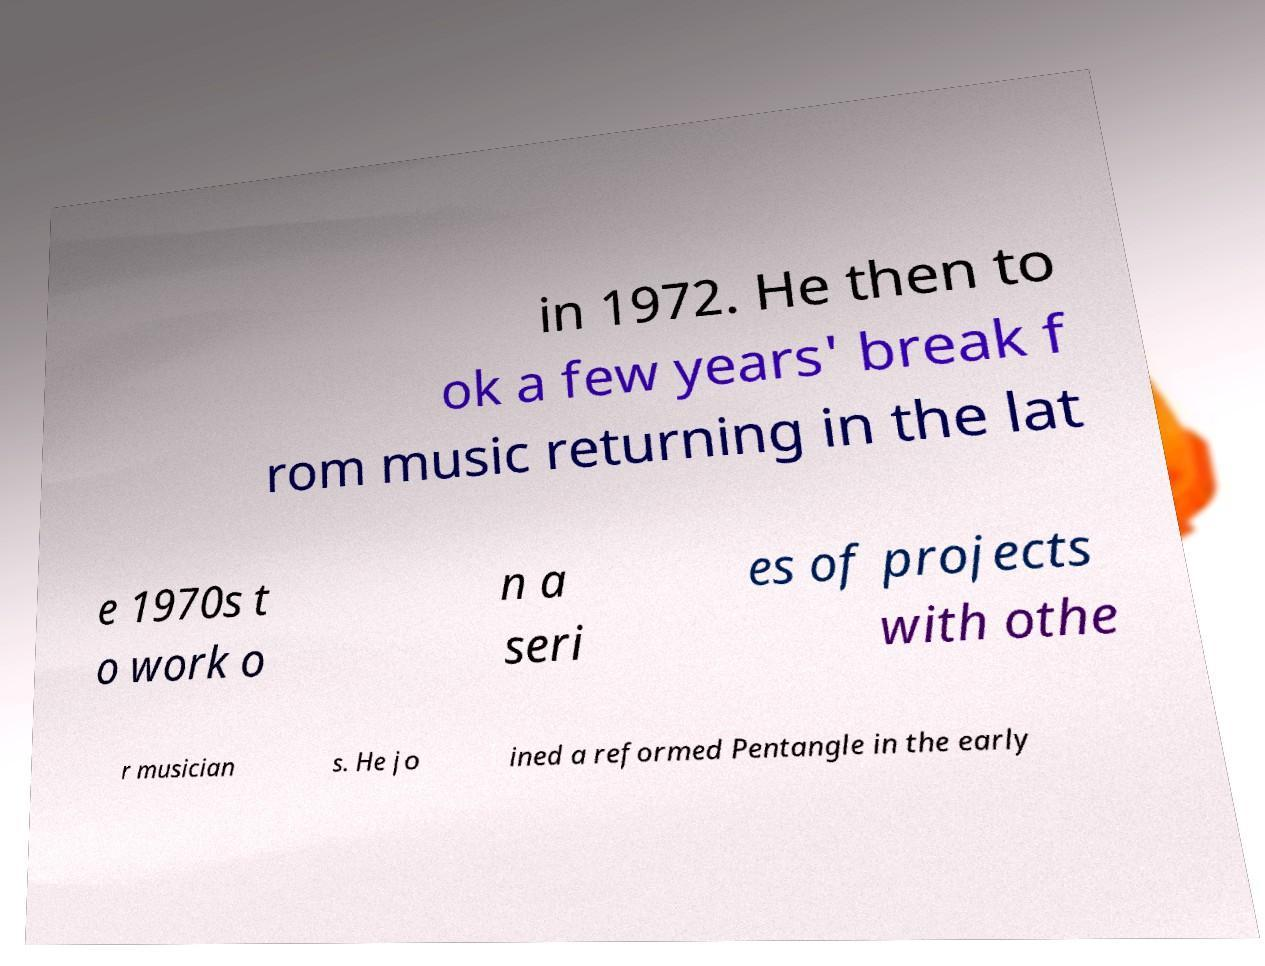There's text embedded in this image that I need extracted. Can you transcribe it verbatim? in 1972. He then to ok a few years' break f rom music returning in the lat e 1970s t o work o n a seri es of projects with othe r musician s. He jo ined a reformed Pentangle in the early 